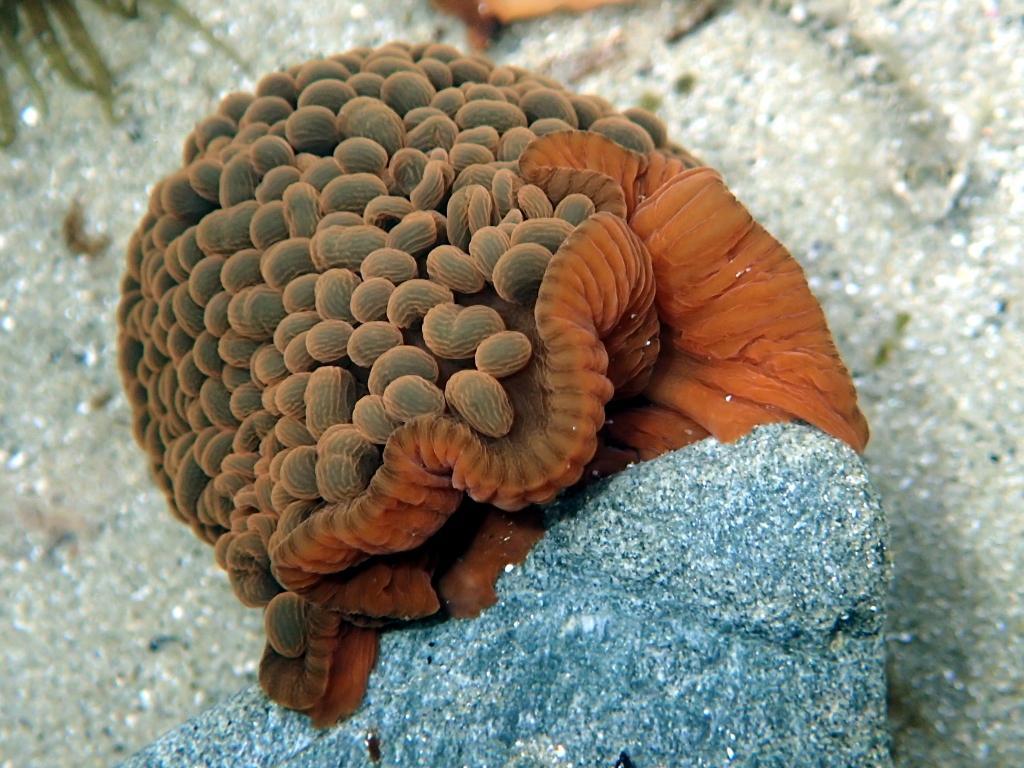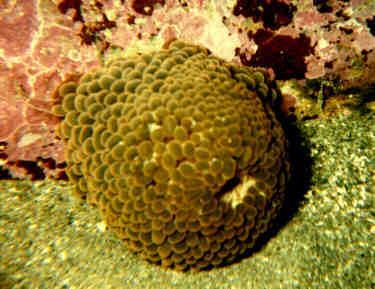The first image is the image on the left, the second image is the image on the right. Analyze the images presented: Is the assertion "The right image shows anemone tendrils emerging from a stalk covered with oval shapes." valid? Answer yes or no. No. 